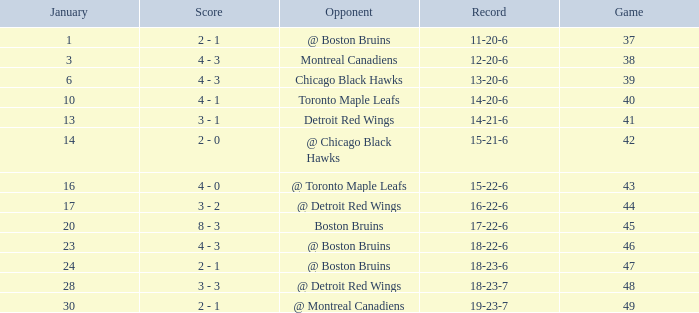Who was the competitor with the 15-21-6 record? @ Chicago Black Hawks. 